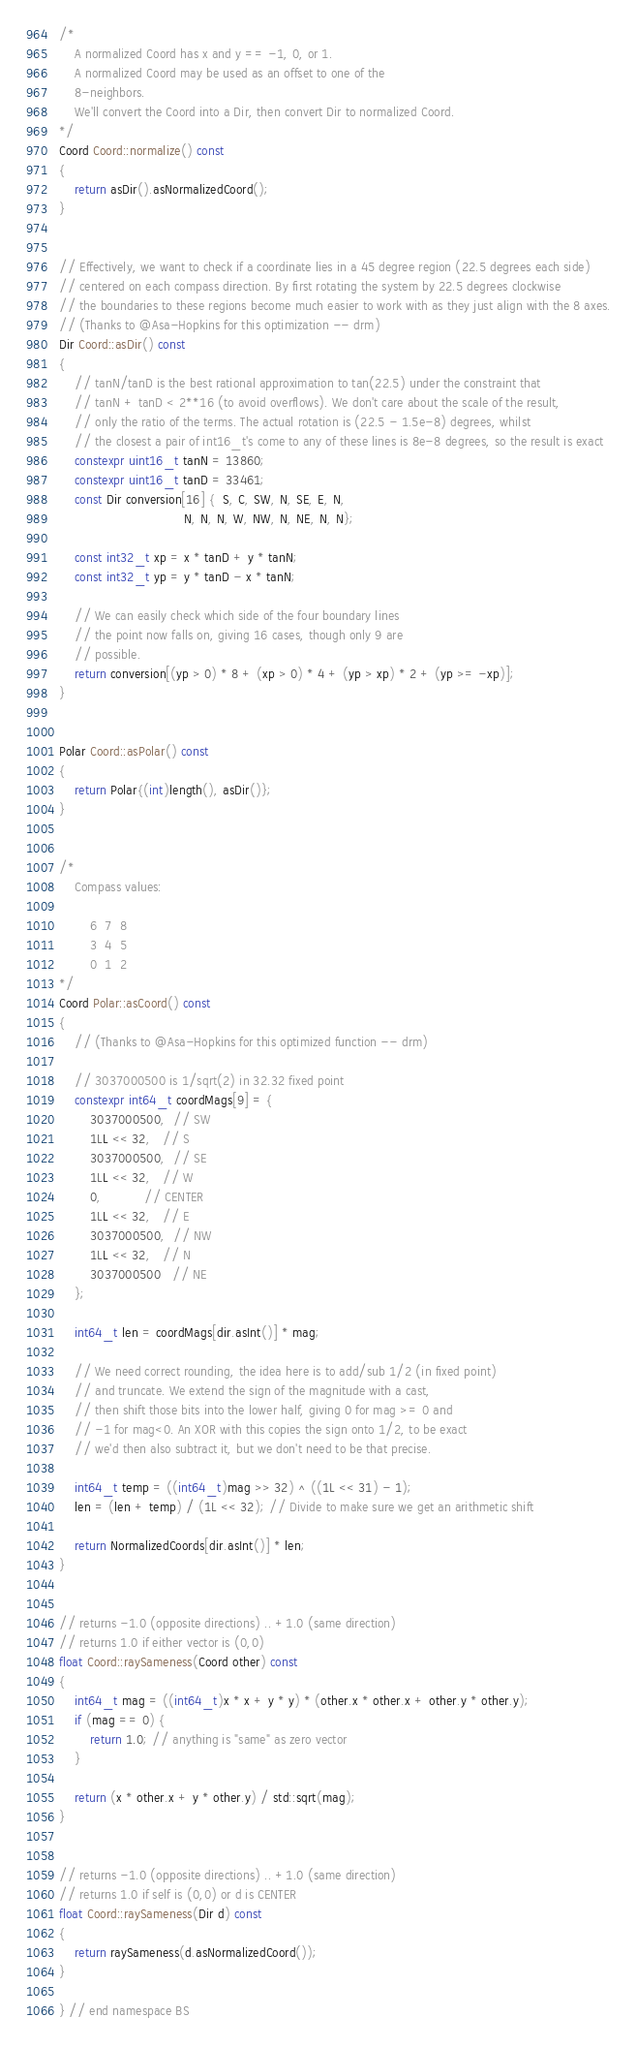<code> <loc_0><loc_0><loc_500><loc_500><_C++_>
/*
    A normalized Coord has x and y == -1, 0, or 1.
    A normalized Coord may be used as an offset to one of the
    8-neighbors.
    We'll convert the Coord into a Dir, then convert Dir to normalized Coord.
*/
Coord Coord::normalize() const
{
    return asDir().asNormalizedCoord();
}


// Effectively, we want to check if a coordinate lies in a 45 degree region (22.5 degrees each side)
// centered on each compass direction. By first rotating the system by 22.5 degrees clockwise
// the boundaries to these regions become much easier to work with as they just align with the 8 axes.
// (Thanks to @Asa-Hopkins for this optimization -- drm)
Dir Coord::asDir() const
{
    // tanN/tanD is the best rational approximation to tan(22.5) under the constraint that
    // tanN + tanD < 2**16 (to avoid overflows). We don't care about the scale of the result,
    // only the ratio of the terms. The actual rotation is (22.5 - 1.5e-8) degrees, whilst
    // the closest a pair of int16_t's come to any of these lines is 8e-8 degrees, so the result is exact
    constexpr uint16_t tanN = 13860;
    constexpr uint16_t tanD = 33461;
    const Dir conversion[16] {  S, C, SW, N, SE, E, N,
                                N, N, N, W, NW, N, NE, N, N};

    const int32_t xp = x * tanD + y * tanN;
    const int32_t yp = y * tanD - x * tanN;

    // We can easily check which side of the four boundary lines
    // the point now falls on, giving 16 cases, though only 9 are
    // possible.
    return conversion[(yp > 0) * 8 + (xp > 0) * 4 + (yp > xp) * 2 + (yp >= -xp)];
}


Polar Coord::asPolar() const
{
    return Polar{(int)length(), asDir()};
}


/*
    Compass values:

        6  7  8
        3  4  5
        0  1  2
*/
Coord Polar::asCoord() const
{
    // (Thanks to @Asa-Hopkins for this optimized function -- drm)

    // 3037000500 is 1/sqrt(2) in 32.32 fixed point
    constexpr int64_t coordMags[9] = {
        3037000500,  // SW
        1LL << 32,   // S
        3037000500,  // SE
        1LL << 32,   // W
        0,           // CENTER
        1LL << 32,   // E
        3037000500,  // NW
        1LL << 32,   // N
        3037000500   // NE
    };

    int64_t len = coordMags[dir.asInt()] * mag;

    // We need correct rounding, the idea here is to add/sub 1/2 (in fixed point)
    // and truncate. We extend the sign of the magnitude with a cast,
    // then shift those bits into the lower half, giving 0 for mag >= 0 and
    // -1 for mag<0. An XOR with this copies the sign onto 1/2, to be exact
    // we'd then also subtract it, but we don't need to be that precise.

    int64_t temp = ((int64_t)mag >> 32) ^ ((1L << 31) - 1);
    len = (len + temp) / (1L << 32); // Divide to make sure we get an arithmetic shift

    return NormalizedCoords[dir.asInt()] * len;
}


// returns -1.0 (opposite directions) .. +1.0 (same direction)
// returns 1.0 if either vector is (0,0)
float Coord::raySameness(Coord other) const
{
    int64_t mag = ((int64_t)x * x + y * y) * (other.x * other.x + other.y * other.y);
    if (mag == 0) {
        return 1.0; // anything is "same" as zero vector
    }

    return (x * other.x + y * other.y) / std::sqrt(mag);
}


// returns -1.0 (opposite directions) .. +1.0 (same direction)
// returns 1.0 if self is (0,0) or d is CENTER
float Coord::raySameness(Dir d) const
{
    return raySameness(d.asNormalizedCoord());
}

} // end namespace BS
</code> 